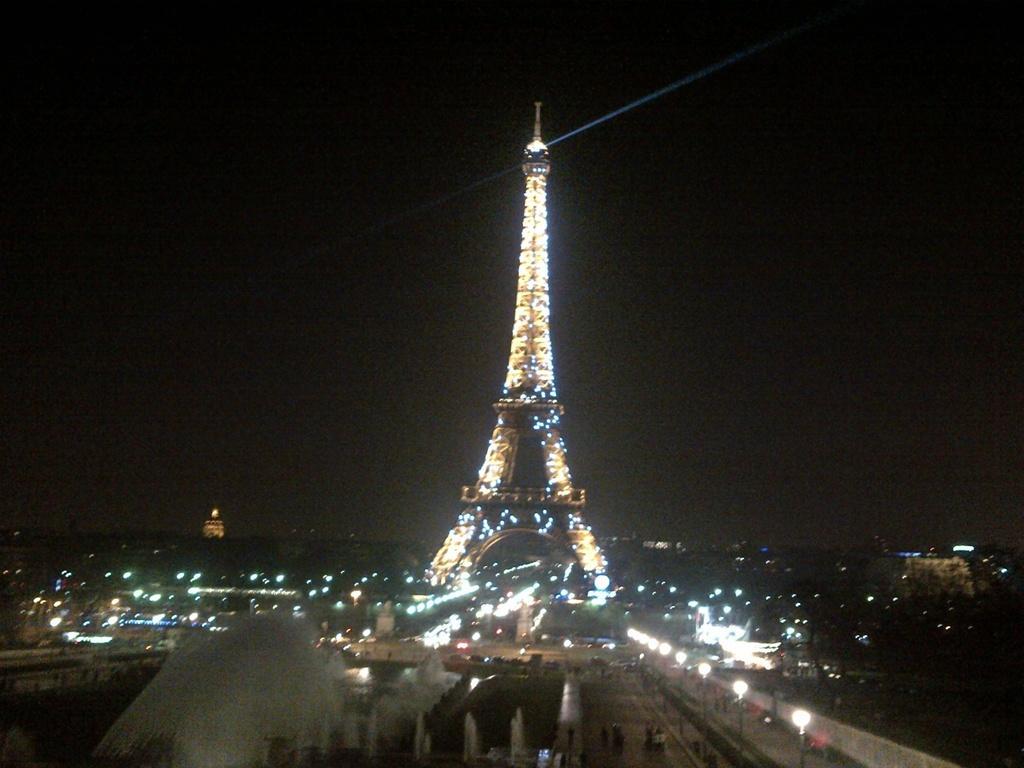Could you give a brief overview of what you see in this image? In the center of the image we can see eiffel tower. At the bottom there is a road and we can see vehicles on the road. There are lights. In the background there are buildings and sky. 